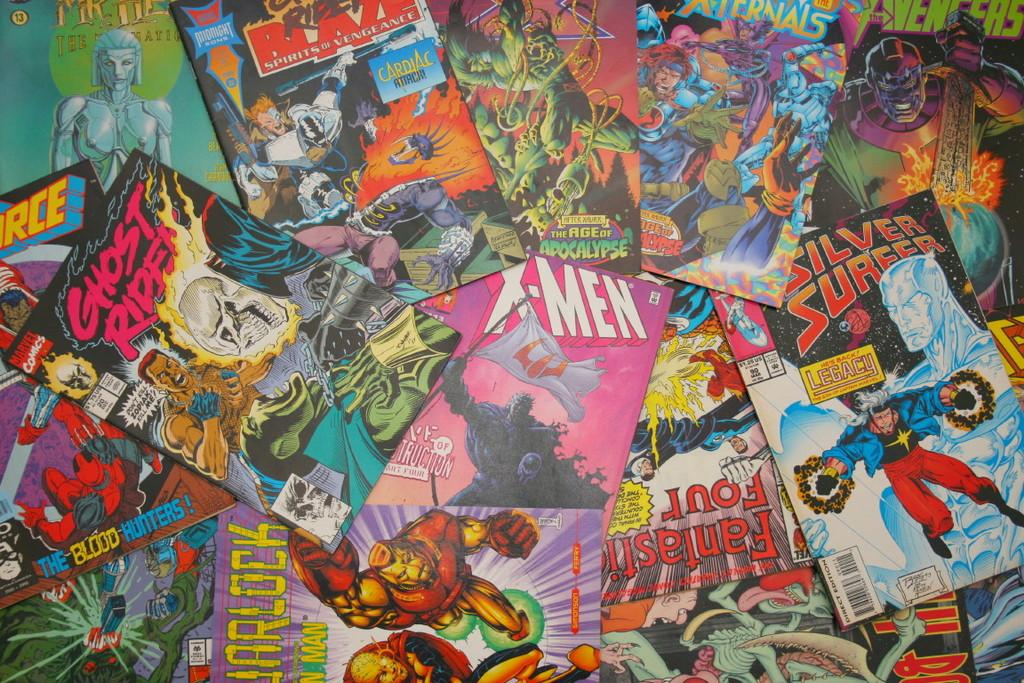<image>
Offer a succinct explanation of the picture presented. A bunch of marvel comic books such as Iron man and X-men. 